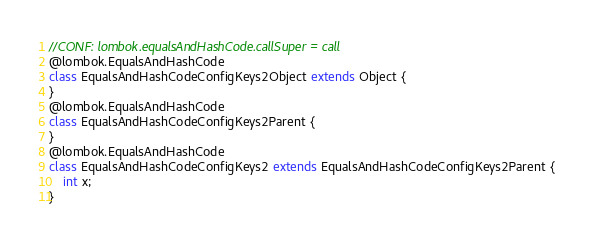<code> <loc_0><loc_0><loc_500><loc_500><_Java_>//CONF: lombok.equalsAndHashCode.callSuper = call
@lombok.EqualsAndHashCode
class EqualsAndHashCodeConfigKeys2Object extends Object {
}
@lombok.EqualsAndHashCode
class EqualsAndHashCodeConfigKeys2Parent {
}
@lombok.EqualsAndHashCode
class EqualsAndHashCodeConfigKeys2 extends EqualsAndHashCodeConfigKeys2Parent {
	int x;
}
</code> 